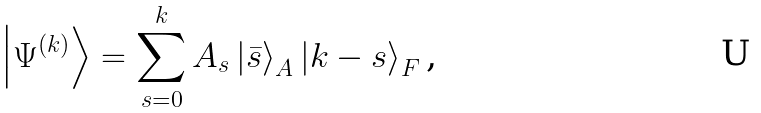Convert formula to latex. <formula><loc_0><loc_0><loc_500><loc_500>\left | \Psi ^ { \left ( k \right ) } \right \rangle = \sum _ { s = 0 } ^ { k } A _ { s } \left | \bar { s } \right \rangle _ { A } \left | k - s \right \rangle _ { F } \text {,}</formula> 